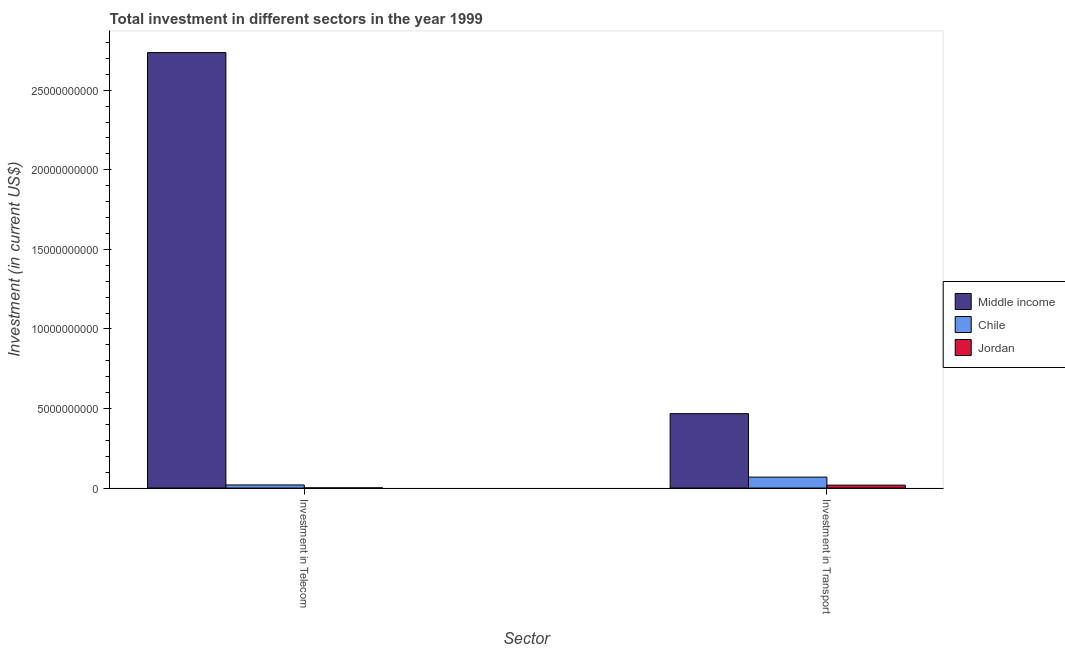How many different coloured bars are there?
Your answer should be compact. 3. How many groups of bars are there?
Ensure brevity in your answer.  2. Are the number of bars per tick equal to the number of legend labels?
Ensure brevity in your answer.  Yes. How many bars are there on the 1st tick from the right?
Give a very brief answer. 3. What is the label of the 2nd group of bars from the left?
Offer a very short reply. Investment in Transport. What is the investment in telecom in Chile?
Provide a succinct answer. 1.95e+08. Across all countries, what is the maximum investment in telecom?
Provide a succinct answer. 2.74e+1. Across all countries, what is the minimum investment in telecom?
Give a very brief answer. 1.18e+07. In which country was the investment in transport maximum?
Keep it short and to the point. Middle income. In which country was the investment in transport minimum?
Provide a short and direct response. Jordan. What is the total investment in transport in the graph?
Your response must be concise. 5.54e+09. What is the difference between the investment in telecom in Middle income and that in Chile?
Your response must be concise. 2.72e+1. What is the difference between the investment in telecom in Middle income and the investment in transport in Chile?
Your response must be concise. 2.67e+1. What is the average investment in transport per country?
Keep it short and to the point. 1.85e+09. What is the difference between the investment in telecom and investment in transport in Jordan?
Provide a succinct answer. -1.70e+08. What is the ratio of the investment in transport in Chile to that in Jordan?
Your response must be concise. 3.77. Is the investment in transport in Jordan less than that in Chile?
Offer a very short reply. Yes. In how many countries, is the investment in transport greater than the average investment in transport taken over all countries?
Your answer should be very brief. 1. What does the 3rd bar from the right in Investment in Telecom represents?
Provide a short and direct response. Middle income. Does the graph contain grids?
Your answer should be very brief. No. How many legend labels are there?
Offer a terse response. 3. What is the title of the graph?
Provide a short and direct response. Total investment in different sectors in the year 1999. What is the label or title of the X-axis?
Give a very brief answer. Sector. What is the label or title of the Y-axis?
Your answer should be compact. Investment (in current US$). What is the Investment (in current US$) in Middle income in Investment in Telecom?
Your response must be concise. 2.74e+1. What is the Investment (in current US$) of Chile in Investment in Telecom?
Provide a short and direct response. 1.95e+08. What is the Investment (in current US$) of Jordan in Investment in Telecom?
Your answer should be very brief. 1.18e+07. What is the Investment (in current US$) in Middle income in Investment in Transport?
Your answer should be very brief. 4.67e+09. What is the Investment (in current US$) of Chile in Investment in Transport?
Your answer should be very brief. 6.87e+08. What is the Investment (in current US$) of Jordan in Investment in Transport?
Provide a succinct answer. 1.82e+08. Across all Sector, what is the maximum Investment (in current US$) of Middle income?
Offer a terse response. 2.74e+1. Across all Sector, what is the maximum Investment (in current US$) in Chile?
Ensure brevity in your answer.  6.87e+08. Across all Sector, what is the maximum Investment (in current US$) in Jordan?
Ensure brevity in your answer.  1.82e+08. Across all Sector, what is the minimum Investment (in current US$) of Middle income?
Provide a short and direct response. 4.67e+09. Across all Sector, what is the minimum Investment (in current US$) in Chile?
Your answer should be very brief. 1.95e+08. Across all Sector, what is the minimum Investment (in current US$) of Jordan?
Provide a short and direct response. 1.18e+07. What is the total Investment (in current US$) of Middle income in the graph?
Your answer should be very brief. 3.20e+1. What is the total Investment (in current US$) of Chile in the graph?
Keep it short and to the point. 8.82e+08. What is the total Investment (in current US$) of Jordan in the graph?
Give a very brief answer. 1.94e+08. What is the difference between the Investment (in current US$) of Middle income in Investment in Telecom and that in Investment in Transport?
Ensure brevity in your answer.  2.27e+1. What is the difference between the Investment (in current US$) of Chile in Investment in Telecom and that in Investment in Transport?
Give a very brief answer. -4.91e+08. What is the difference between the Investment (in current US$) of Jordan in Investment in Telecom and that in Investment in Transport?
Ensure brevity in your answer.  -1.70e+08. What is the difference between the Investment (in current US$) in Middle income in Investment in Telecom and the Investment (in current US$) in Chile in Investment in Transport?
Offer a terse response. 2.67e+1. What is the difference between the Investment (in current US$) of Middle income in Investment in Telecom and the Investment (in current US$) of Jordan in Investment in Transport?
Ensure brevity in your answer.  2.72e+1. What is the difference between the Investment (in current US$) of Chile in Investment in Telecom and the Investment (in current US$) of Jordan in Investment in Transport?
Give a very brief answer. 1.34e+07. What is the average Investment (in current US$) of Middle income per Sector?
Provide a succinct answer. 1.60e+1. What is the average Investment (in current US$) in Chile per Sector?
Offer a very short reply. 4.41e+08. What is the average Investment (in current US$) of Jordan per Sector?
Make the answer very short. 9.69e+07. What is the difference between the Investment (in current US$) of Middle income and Investment (in current US$) of Chile in Investment in Telecom?
Make the answer very short. 2.72e+1. What is the difference between the Investment (in current US$) in Middle income and Investment (in current US$) in Jordan in Investment in Telecom?
Provide a short and direct response. 2.74e+1. What is the difference between the Investment (in current US$) of Chile and Investment (in current US$) of Jordan in Investment in Telecom?
Offer a very short reply. 1.84e+08. What is the difference between the Investment (in current US$) of Middle income and Investment (in current US$) of Chile in Investment in Transport?
Your answer should be very brief. 3.99e+09. What is the difference between the Investment (in current US$) of Middle income and Investment (in current US$) of Jordan in Investment in Transport?
Keep it short and to the point. 4.49e+09. What is the difference between the Investment (in current US$) in Chile and Investment (in current US$) in Jordan in Investment in Transport?
Make the answer very short. 5.05e+08. What is the ratio of the Investment (in current US$) in Middle income in Investment in Telecom to that in Investment in Transport?
Provide a short and direct response. 5.85. What is the ratio of the Investment (in current US$) of Chile in Investment in Telecom to that in Investment in Transport?
Provide a short and direct response. 0.28. What is the ratio of the Investment (in current US$) of Jordan in Investment in Telecom to that in Investment in Transport?
Offer a terse response. 0.06. What is the difference between the highest and the second highest Investment (in current US$) of Middle income?
Offer a terse response. 2.27e+1. What is the difference between the highest and the second highest Investment (in current US$) of Chile?
Offer a terse response. 4.91e+08. What is the difference between the highest and the second highest Investment (in current US$) in Jordan?
Ensure brevity in your answer.  1.70e+08. What is the difference between the highest and the lowest Investment (in current US$) in Middle income?
Your answer should be very brief. 2.27e+1. What is the difference between the highest and the lowest Investment (in current US$) in Chile?
Provide a short and direct response. 4.91e+08. What is the difference between the highest and the lowest Investment (in current US$) of Jordan?
Provide a succinct answer. 1.70e+08. 